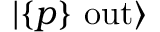<formula> <loc_0><loc_0><loc_500><loc_500>| \{ p \} \ o u t \rangle</formula> 